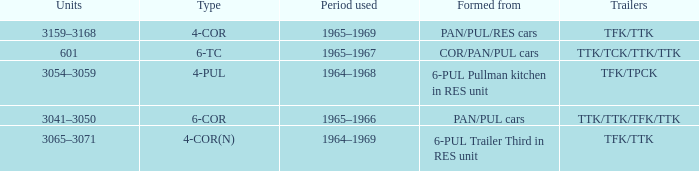Name the trailers for formed from pan/pul/res cars TFK/TTK. 